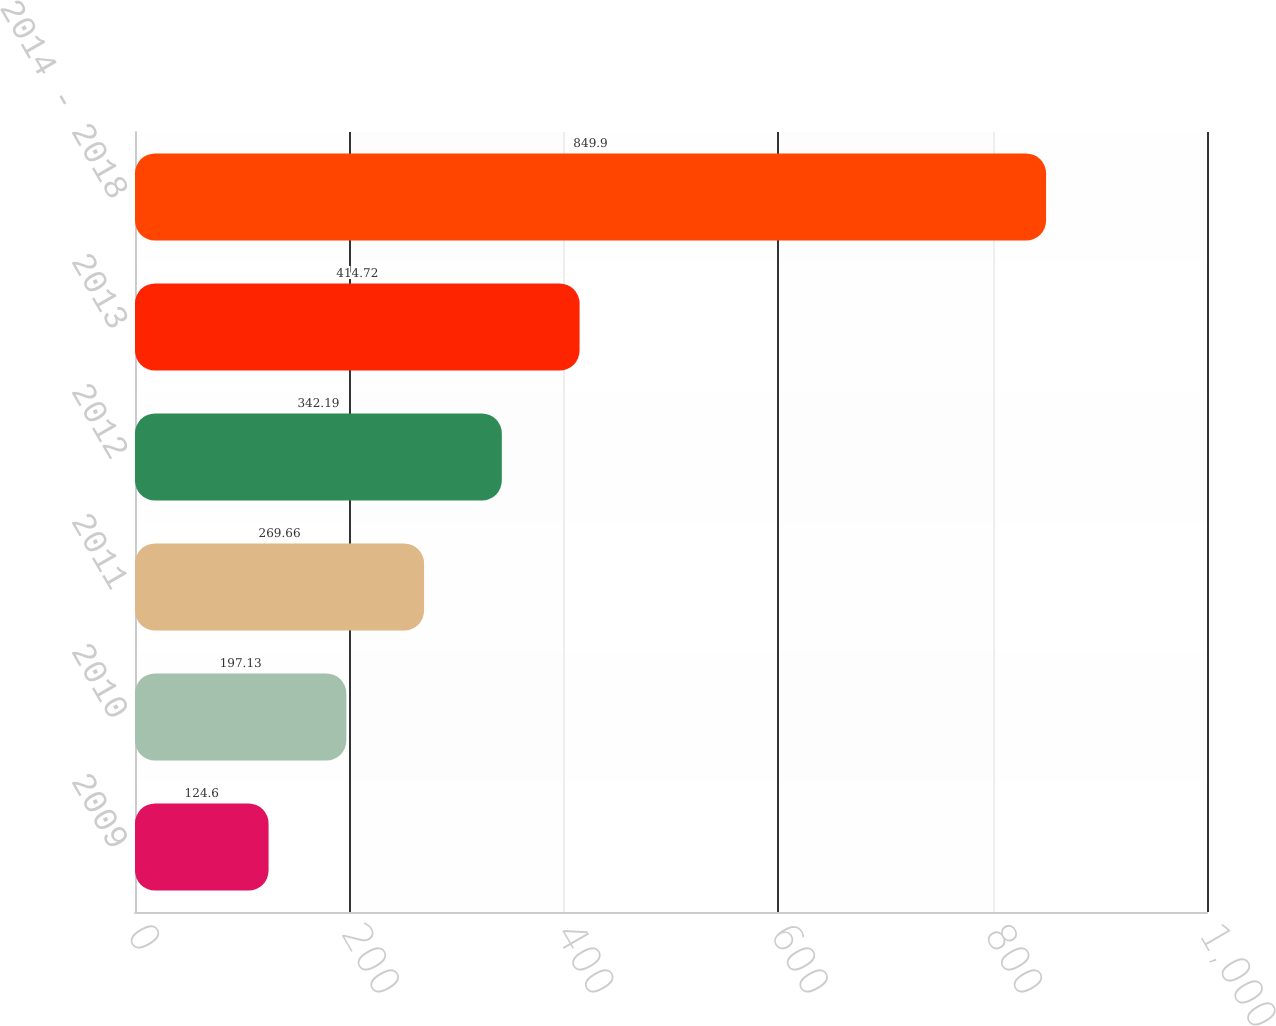Convert chart to OTSL. <chart><loc_0><loc_0><loc_500><loc_500><bar_chart><fcel>2009<fcel>2010<fcel>2011<fcel>2012<fcel>2013<fcel>2014 - 2018<nl><fcel>124.6<fcel>197.13<fcel>269.66<fcel>342.19<fcel>414.72<fcel>849.9<nl></chart> 